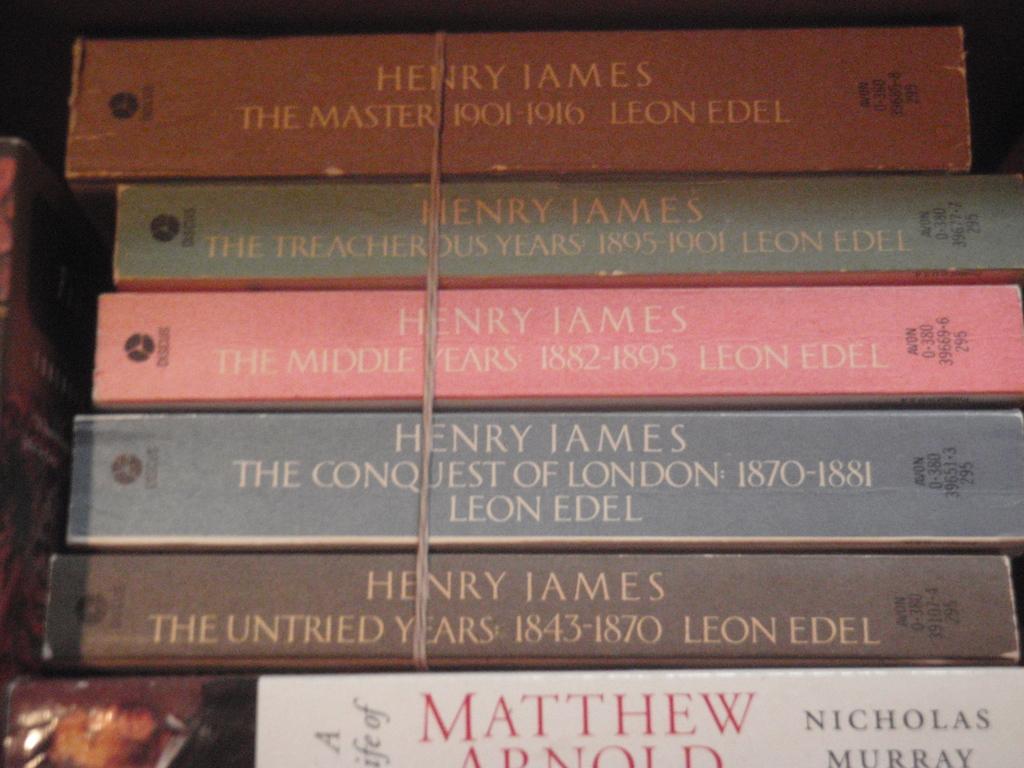Who is the author of the book at the bottom?
Provide a short and direct response. Nicholas murray. 